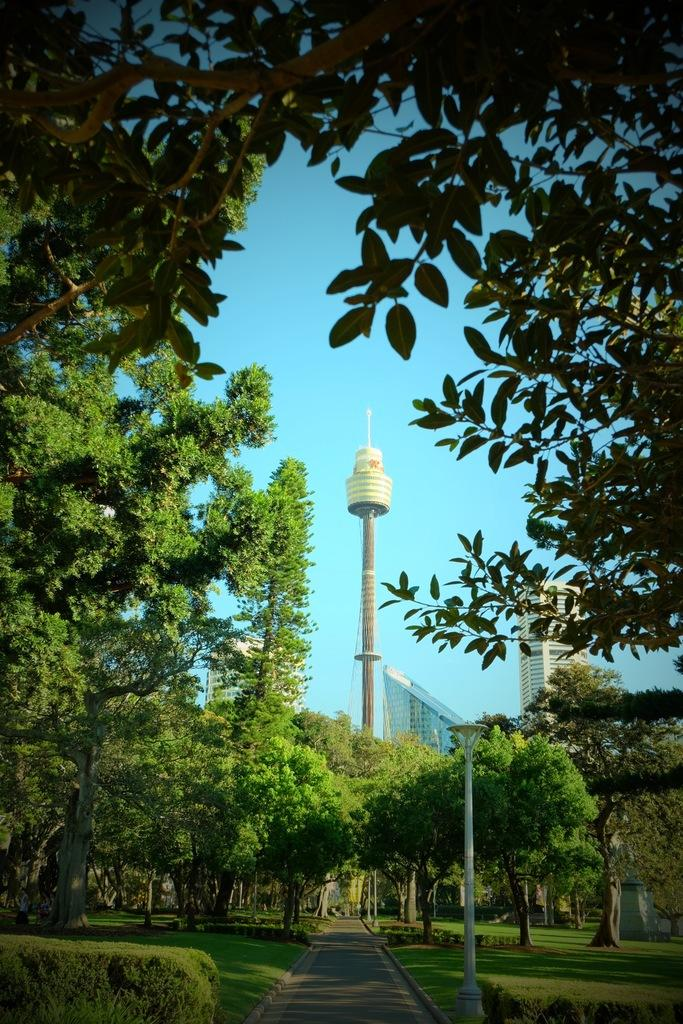What is the main surface in the center of the image? There is a pavement in the center of the image. What type of vegetation is located beside the pavement? There is grass beside the pavement. What other types of vegetation can be seen in the image? Bushes and trees are visible in the image. What structures are present along the pavement? Lamp posts are in the image. What can be seen in the background of the image? There are buildings in the background of the image. How many facts are visible in the image? The term "facts" does not refer to a visible object or element in the image. --- Facts: 1. There is a person holding a book in the image. 2. The person is sitting on a chair. 3. The chair is made of wood. 4. There is a table in front of the chair. 5. The table has a lamp on it. Absurd Topics: elephant, ocean, dance Conversation: What is the person in the image holding? The person in the image is holding a book. What is the person sitting on? The person is sitting on a chair. What material is the chair made of? The chair is made of wood. What is in front of the chair? There is a table in front of the chair. What is on the table? The table has a lamp on it. Reasoning: Let's think step by step in order to produce the conversation. We start by identifying the main subject in the image, which is the person holding a book. Then, we describe the person's position and the chair they are sitting on, including the material it is made of. Next, we mention the presence of a table in front of the chair. Finally, we acknowledge the object on the table, which is a lamp. Each question is designed to elicit a specific detail about the image that is known from the provided facts. Absurd Question/Answer: Can you see an elephant swimming in the ocean in the image? No, there is no elephant or ocean present in the image. 